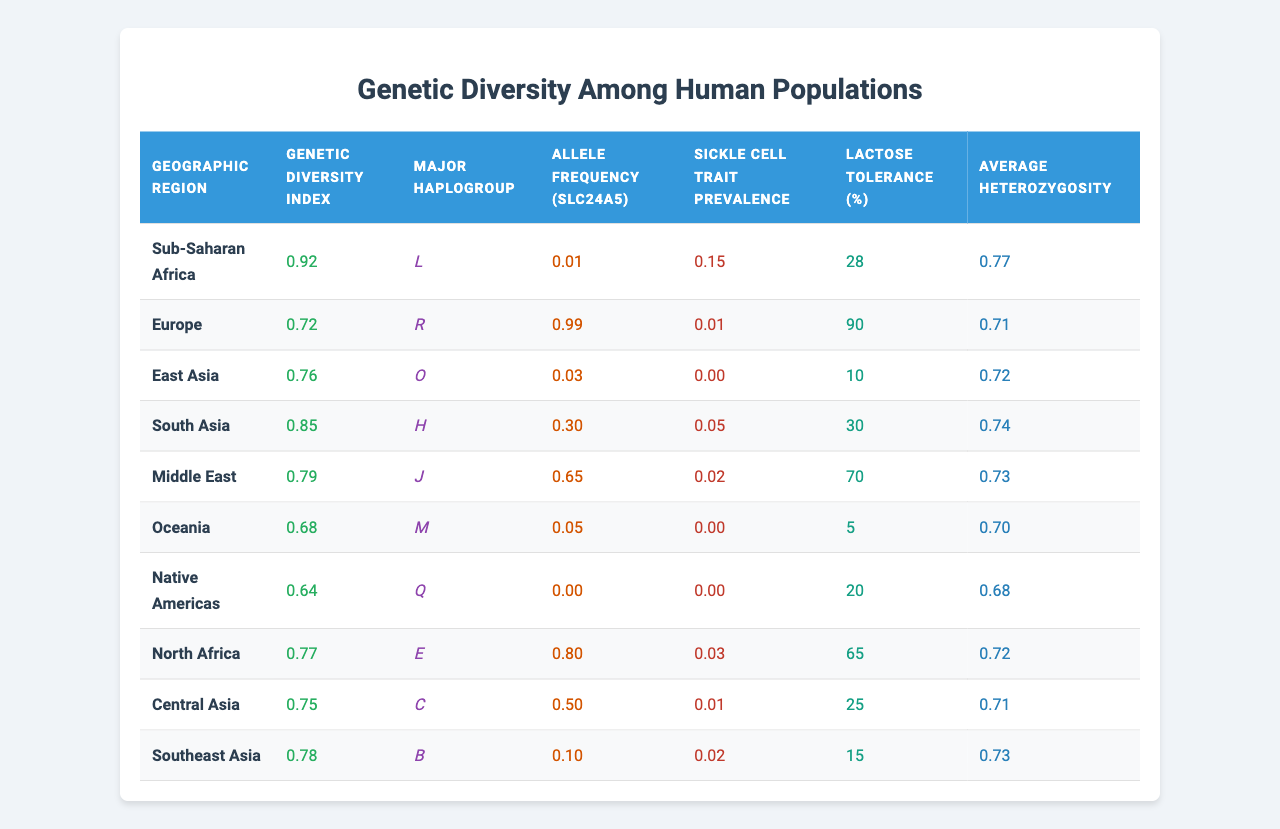What is the Genetic Diversity Index for Europe? The Genetic Diversity Index for Europe is presented in the table under the corresponding column. It shows a value of 0.72 for Europe.
Answer: 0.72 Which region has the highest Lactose Tolerance percentage? By reading the Lactose Tolerance column, we see that Europe has the highest percentage at 90%.
Answer: 90% What is the Sickle Cell Trait Prevalence in Sub-Saharan Africa? The table specifies that the Sickle Cell Trait Prevalence in Sub-Saharan Africa is 0.15, directly noted in the corresponding column.
Answer: 0.15 What is the average Lactose Tolerance percentage across all regions? To find the average, sum the Lactose Tolerance percentages: 28 + 90 + 10 + 30 + 70 + 5 + 20 + 65 + 25 + 15 =  358. There are 10 regions, so the average is 358 / 10 = 35.8.
Answer: 35.8 Among which regions is the Sickle Cell Trait Prevalence greater than 0.01? Look at the Sickle Cell Trait Prevalence column and identify the regions where the value is greater than 0.01. These regions are Sub-Saharan Africa (0.15), South Asia (0.05), Middle East (0.02), and North Africa (0.03).
Answer: Sub-Saharan Africa, South Asia, Middle East, North Africa Which region has the lowest Average Heterozygosity? By checking the Average Heterozygosity column, Native Americas has the lowest value at 0.68.
Answer: 0.68 Is it true that East Asia has a higher Genetic Diversity Index than Native Americas? Compare the Genetic Diversity Index values in their respective rows; East Asia (0.76) is higher than Native Americas (0.64). Therefore, it is true.
Answer: True What is the difference in average Genetic Diversity Index between Sub-Saharan Africa and Oceania? First, find both indices: Sub-Saharan Africa is 0.92, and Oceania is 0.68. The difference is calculated as 0.92 - 0.68 = 0.24.
Answer: 0.24 Identify the major haplogroup for the region with the highest Sickle Cell Trait Prevalence. Sub-Saharan Africa has the highest Sickle Cell Trait Prevalence (0.15) and its corresponding major haplogroup from the table is L.
Answer: L What percentage of the population in Southeast Asia exhibits Lactose Tolerance? The Lactose Tolerance percentage for Southeast Asia is listed in the table as 15%.
Answer: 15% Which two regions have the same Average Heterozygosity value? Examining the Average Heterozygosity column reveals that Europe (0.71) and Central Asia (0.71) share the same value.
Answer: Europe, Central Asia 